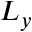<formula> <loc_0><loc_0><loc_500><loc_500>L _ { y }</formula> 